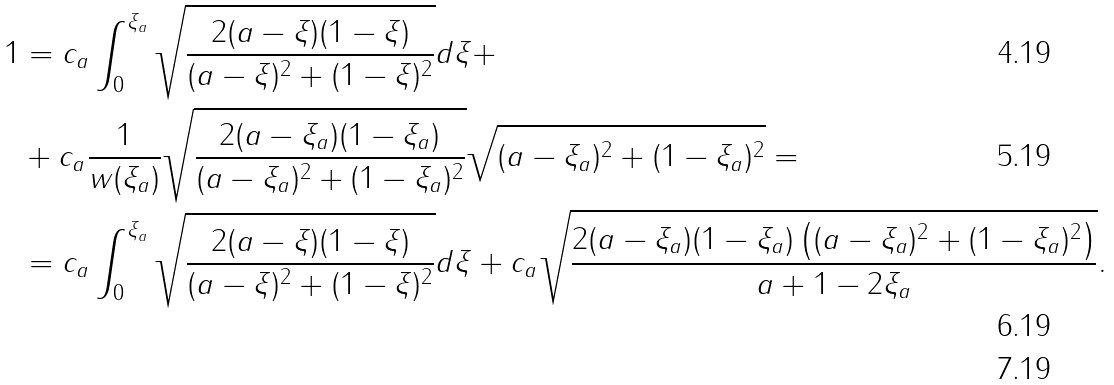Convert formula to latex. <formula><loc_0><loc_0><loc_500><loc_500>1 & = c _ { a } \int _ { 0 } ^ { \xi _ { a } } \sqrt { \frac { 2 ( a - \xi ) ( 1 - \xi ) } { ( a - \xi ) ^ { 2 } + ( 1 - \xi ) ^ { 2 } } } d \xi + \\ & + c _ { a } \frac { 1 } { w ( \xi _ { a } ) } \sqrt { \frac { 2 ( a - \xi _ { a } ) ( 1 - \xi _ { a } ) } { ( a - \xi _ { a } ) ^ { 2 } + ( 1 - \xi _ { a } ) ^ { 2 } } } \sqrt { ( a - \xi _ { a } ) ^ { 2 } + ( 1 - \xi _ { a } ) ^ { 2 } } = \\ & = c _ { a } \int _ { 0 } ^ { \xi _ { a } } \sqrt { \frac { 2 ( a - \xi ) ( 1 - \xi ) } { ( a - \xi ) ^ { 2 } + ( 1 - \xi ) ^ { 2 } } } d \xi + c _ { a } \sqrt { \frac { 2 ( a - \xi _ { a } ) ( 1 - \xi _ { a } ) \left ( ( a - \xi _ { a } ) ^ { 2 } + ( 1 - \xi _ { a } ) ^ { 2 } \right ) } { a + 1 - 2 \xi _ { a } } } . \\</formula> 